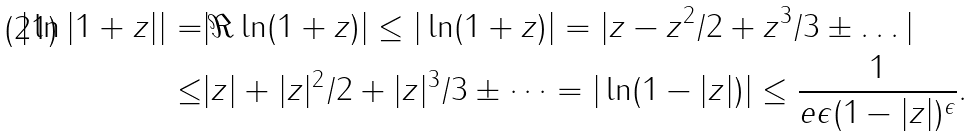Convert formula to latex. <formula><loc_0><loc_0><loc_500><loc_500>| \ln | 1 + z | | = & | \Re \ln ( 1 + z ) | \leq | \ln ( 1 + z ) | = | z - z ^ { 2 } / 2 + z ^ { 3 } / 3 \pm \dots | \\ \leq & | z | + | z | ^ { 2 } / 2 + | z | ^ { 3 } / 3 \pm \dots = | \ln ( 1 - | z | ) | \leq \frac { 1 } { e \epsilon ( 1 - | z | ) ^ { \epsilon } } .</formula> 